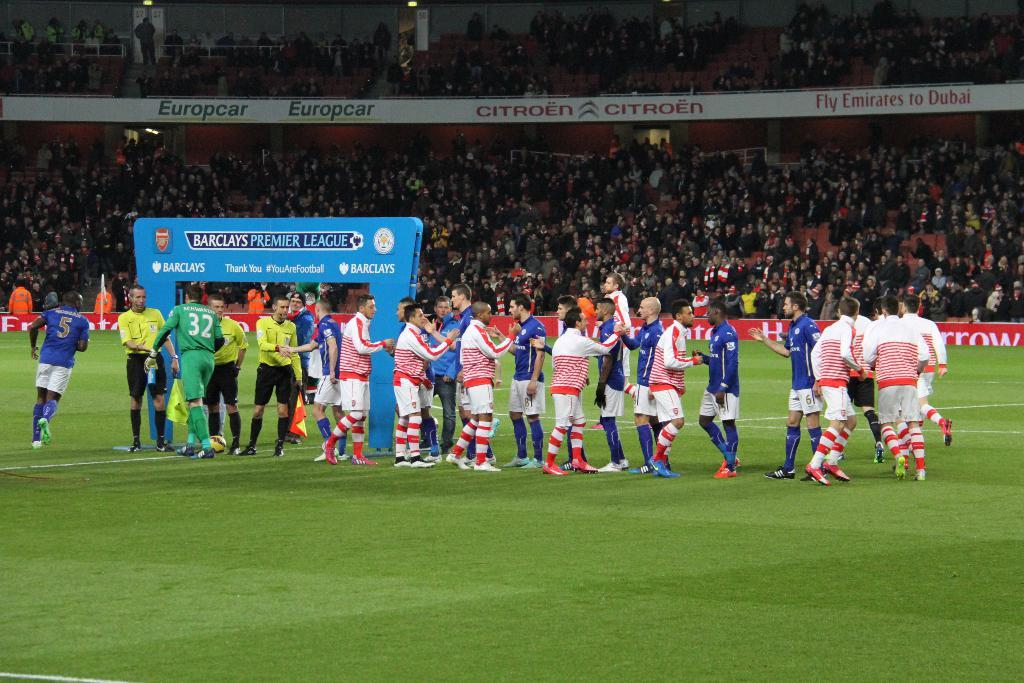<image>
Create a compact narrative representing the image presented. an ad for citroen for a soccer field 